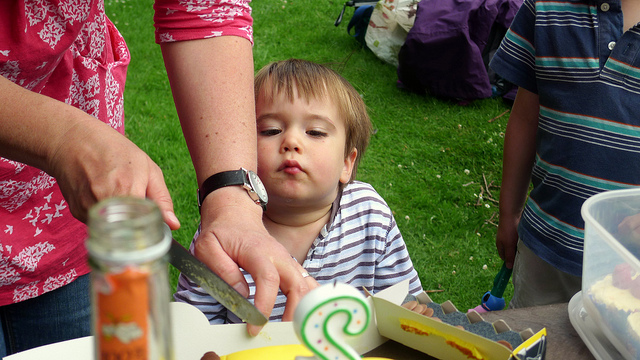Describe the mood captured in the image. The image captures a moment of tranquility and the laid-back vibe of an outdoor gathering. The child in the foreground seems relaxed or tired, with their eyes closed and head supported by an adult's hand, reinforcing the sense of a peaceful, family-friendly atmosphere. Could you guess the time of day this picture was likely taken? While precise estimation is challenging without direct clues such as the position of the sun or shadows, the natural daylight and the casual setting may suggest the picture was taken during the daytime, possibly around lunch or in the early afternoon. 